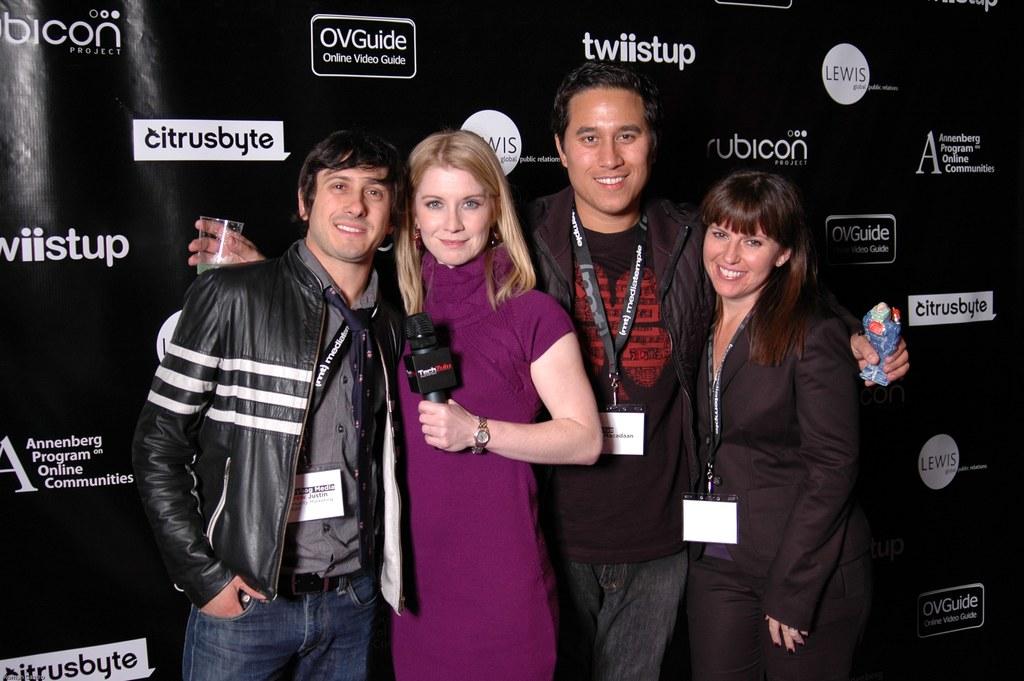What does the ov in ovguide stand for?
Your response must be concise. Online video. 